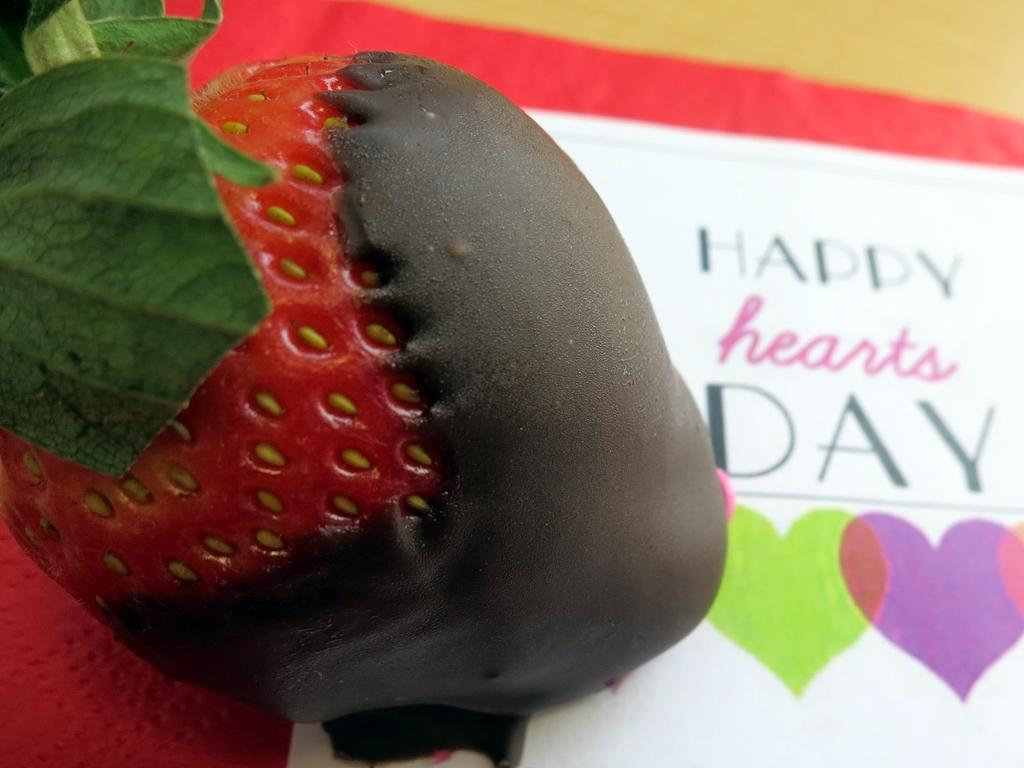What is the main food item featured in the image? There is a strawberry dipped in chocolate in the image. What can be seen in the background of the image? There is a wall in the image. Is there anything attached to the wall? Yes, there is a banner attached to the wall. What type of ink is used to write on the banner in the image? There is no writing on the banner in the image, so it is not possible to determine the type of ink used. 